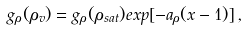Convert formula to latex. <formula><loc_0><loc_0><loc_500><loc_500>g _ { \rho } ( \rho _ { v } ) = g _ { \rho } ( \rho _ { s a t } ) e x p [ - a _ { \rho } ( x - 1 ) ] \, ,</formula> 